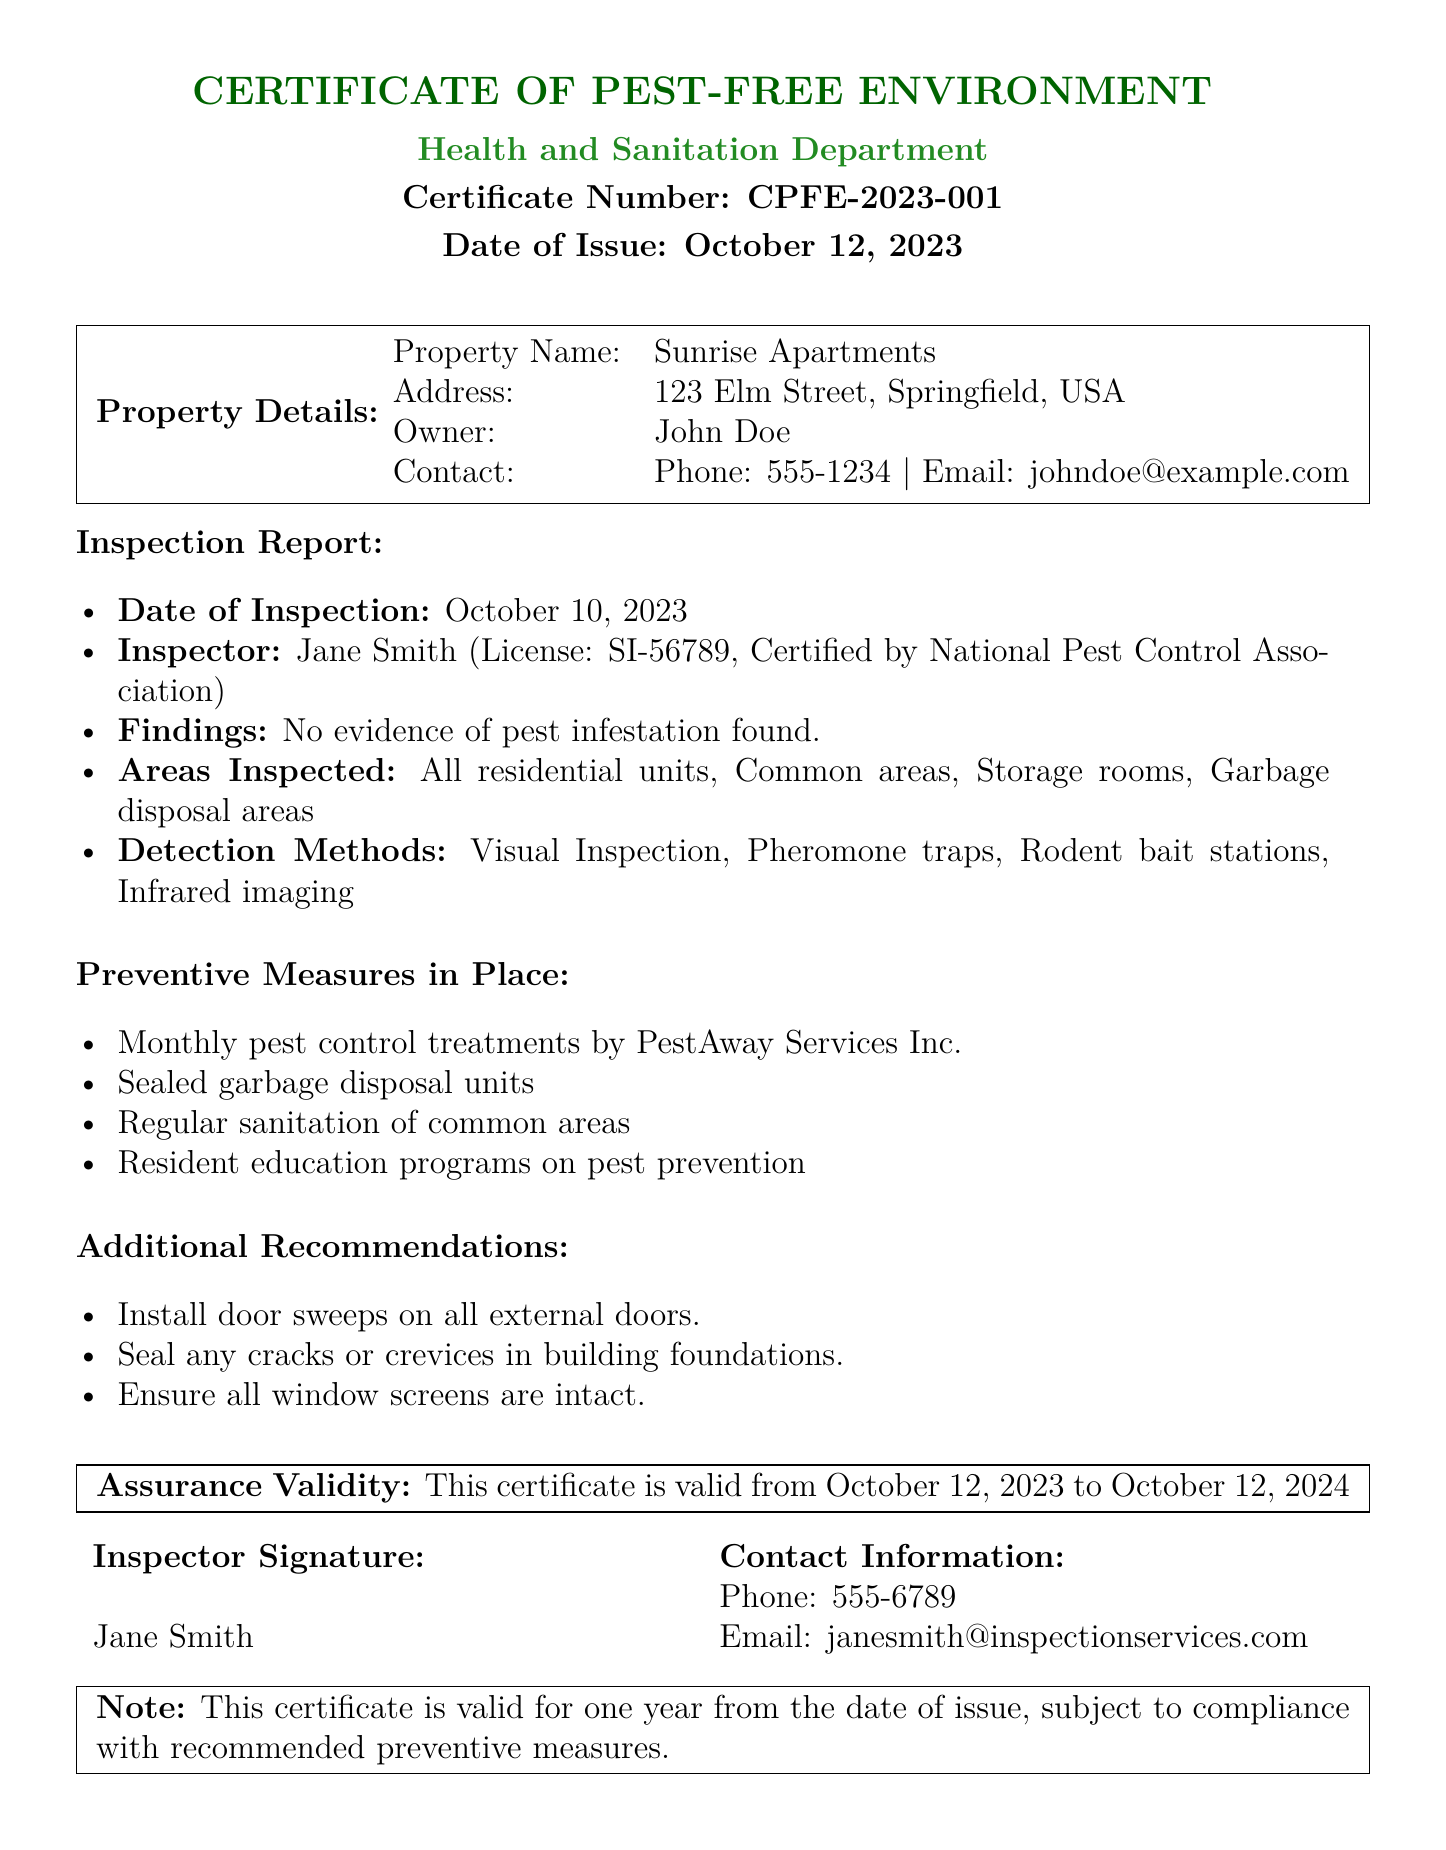What is the certificate number? The certificate number is a unique identifier for the document, listed prominently.
Answer: CPFE-2023-001 Who is the property owner? The owner's name is provided in the property details section of the certificate.
Answer: John Doe What is the date of inspection? The date when the inspection was completed is explicitly stated in the report.
Answer: October 10, 2023 What does the inspection report confirm? The findings section of the inspection report summarizes the outcome of the inspection.
Answer: No evidence of pest infestation found What is the validity period of the certificate? The assurance validity period is specified in the document.
Answer: October 12, 2023 to October 12, 2024 Who conducted the inspection? The inspector's name and credentials are included in the report.
Answer: Jane Smith What is one preventive measure mentioned? The document lists various preventive measures to maintain a pest-free environment.
Answer: Monthly pest control treatments by PestAway Services Inc What is the phone number of the inspector? The contact information for the inspector is provided at the end of the document.
Answer: 555-6789 What is stated about compliance? The note at the end mentions conditions for maintaining the validity of the certificate.
Answer: Subject to compliance with recommended preventive measures 